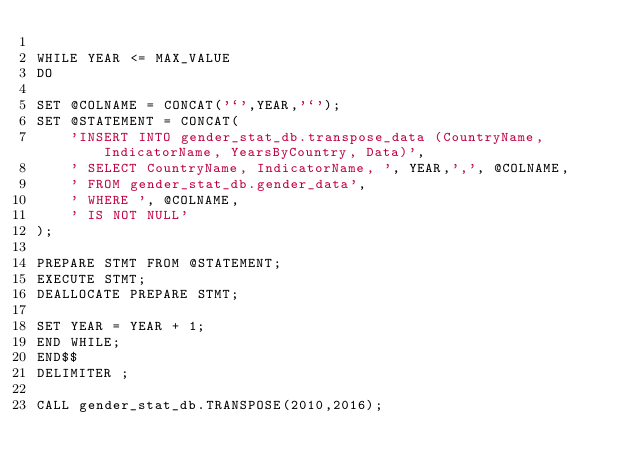Convert code to text. <code><loc_0><loc_0><loc_500><loc_500><_SQL_>
WHILE YEAR <= MAX_VALUE 
DO

SET @COLNAME = CONCAT('`',YEAR,'`');
SET @STATEMENT = CONCAT(
    'INSERT INTO gender_stat_db.transpose_data (CountryName, IndicatorName, YearsByCountry, Data)',
    ' SELECT CountryName, IndicatorName, ', YEAR,',', @COLNAME,
    ' FROM gender_stat_db.gender_data',
    ' WHERE ', @COLNAME,
    ' IS NOT NULL'
);

PREPARE STMT FROM @STATEMENT;
EXECUTE STMT;
DEALLOCATE PREPARE STMT;

SET YEAR = YEAR + 1;
END WHILE;
END$$
DELIMITER ;

CALL gender_stat_db.TRANSPOSE(2010,2016);</code> 